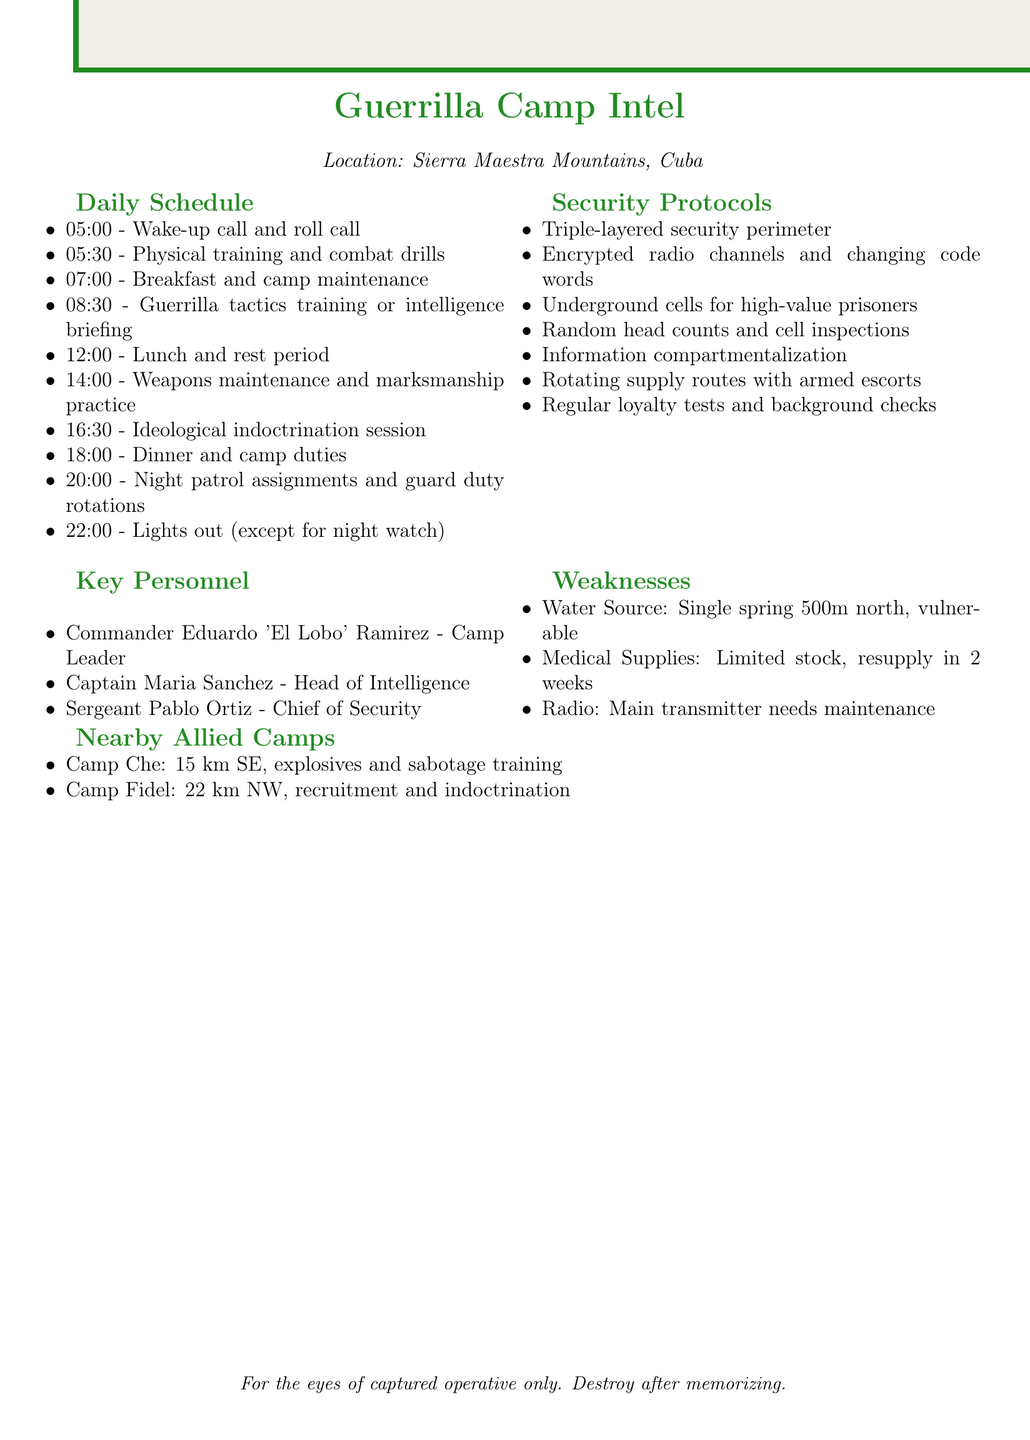What time does lights out occur? Lights out is at 22:00, as stated in the daily schedule section of the document.
Answer: 22:00 Who is the Chief of Security? The Chief of Security, as outlined in the key personnel section, is Sergeant Pablo Ortiz.
Answer: Sergeant Pablo Ortiz What kind of security perimeter is established? The document indicates a triple-layered security perimeter as part of the security protocols.
Answer: Triple-layered security perimeter How far is Camp Che from this camp? The distance of Camp Che from this camp is specified to be 15 km southeast.
Answer: 15 km southeast What is the vulnerability of the water source? The document mentions that the single mountain spring is vulnerable to contamination.
Answer: Vulnerable to contamination What session is scheduled at 16:30? At 16:30, an ideological indoctrination session is scheduled according to the daily schedule.
Answer: Ideological indoctrination session What is the main weakness related to medical supplies? The document indicates that there is a limited stock of antibiotics and painkillers with resupply expected in 2 weeks.
Answer: Limited stock; resupply in 2 weeks What measures are taken for prisoner containment? The document states that high-value prisoners are kept in reinforced underground cells with 24/7 armed guard.
Answer: Reinforced underground cells with 24/7 armed guard 